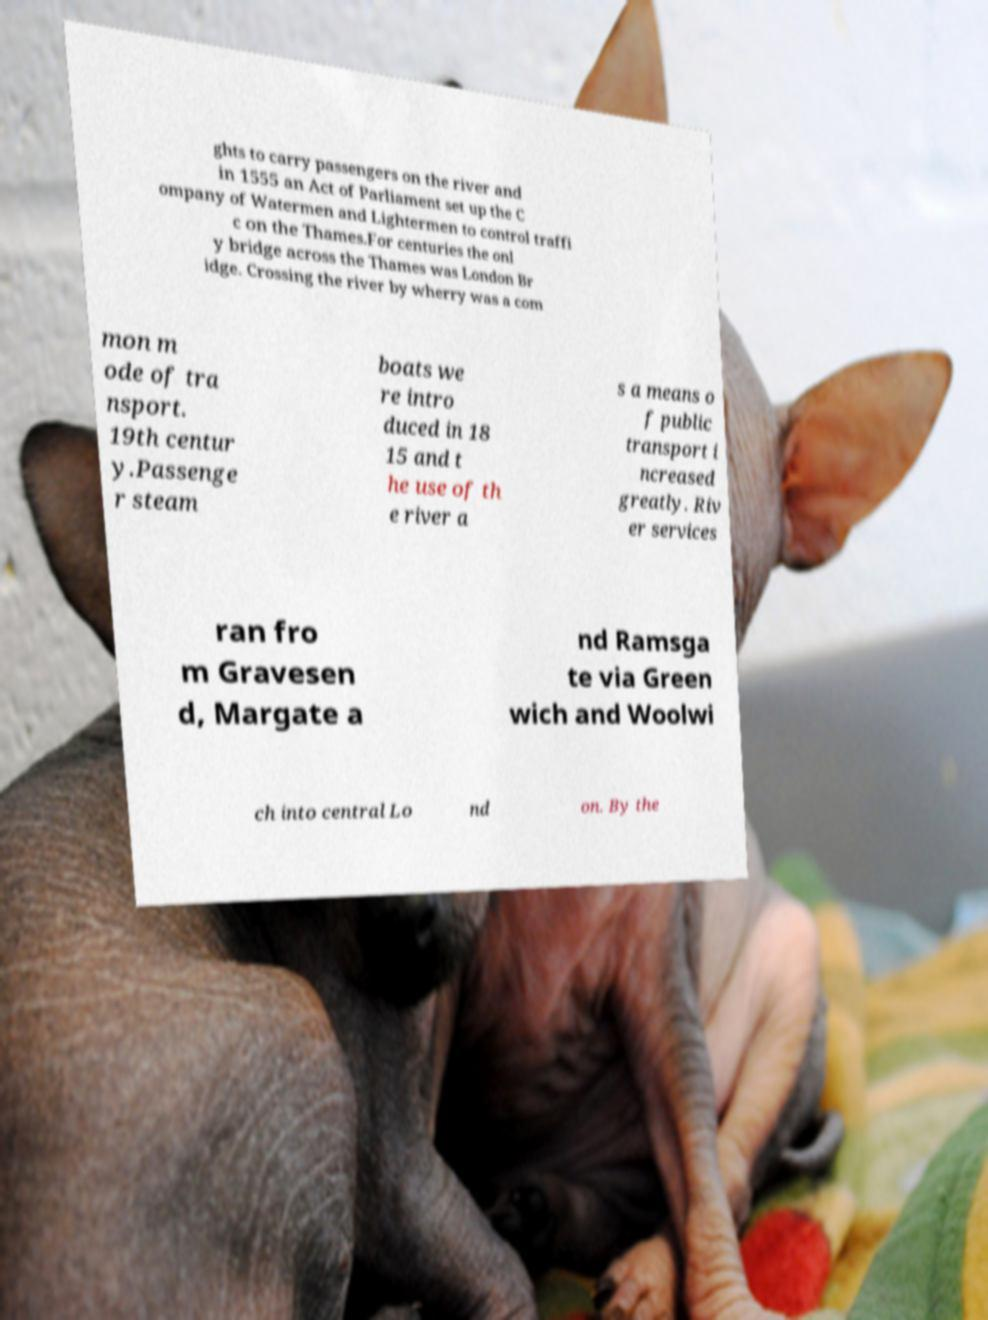What messages or text are displayed in this image? I need them in a readable, typed format. ghts to carry passengers on the river and in 1555 an Act of Parliament set up the C ompany of Watermen and Lightermen to control traffi c on the Thames.For centuries the onl y bridge across the Thames was London Br idge. Crossing the river by wherry was a com mon m ode of tra nsport. 19th centur y.Passenge r steam boats we re intro duced in 18 15 and t he use of th e river a s a means o f public transport i ncreased greatly. Riv er services ran fro m Gravesen d, Margate a nd Ramsga te via Green wich and Woolwi ch into central Lo nd on. By the 